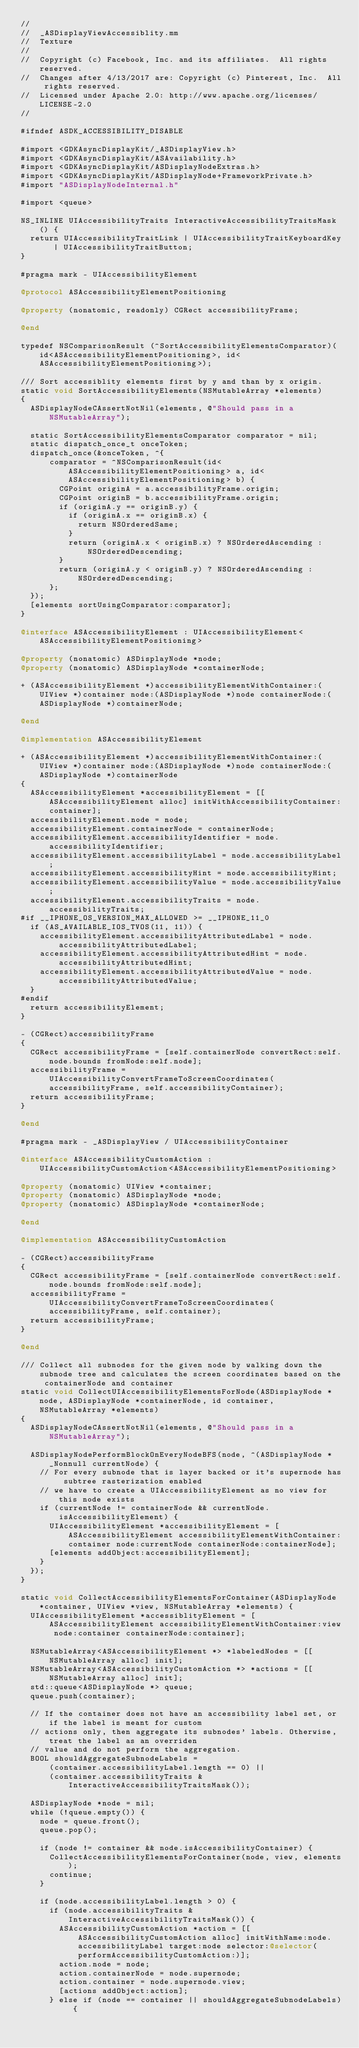<code> <loc_0><loc_0><loc_500><loc_500><_ObjectiveC_>//
//  _ASDisplayViewAccessiblity.mm
//  Texture
//
//  Copyright (c) Facebook, Inc. and its affiliates.  All rights reserved.
//  Changes after 4/13/2017 are: Copyright (c) Pinterest, Inc.  All rights reserved.
//  Licensed under Apache 2.0: http://www.apache.org/licenses/LICENSE-2.0
//

#ifndef ASDK_ACCESSIBILITY_DISABLE

#import <GDKAsyncDisplayKit/_ASDisplayView.h>
#import <GDKAsyncDisplayKit/ASAvailability.h>
#import <GDKAsyncDisplayKit/ASDisplayNodeExtras.h>
#import <GDKAsyncDisplayKit/ASDisplayNode+FrameworkPrivate.h>
#import "ASDisplayNodeInternal.h"

#import <queue>

NS_INLINE UIAccessibilityTraits InteractiveAccessibilityTraitsMask() {
  return UIAccessibilityTraitLink | UIAccessibilityTraitKeyboardKey | UIAccessibilityTraitButton;
}

#pragma mark - UIAccessibilityElement

@protocol ASAccessibilityElementPositioning

@property (nonatomic, readonly) CGRect accessibilityFrame;

@end

typedef NSComparisonResult (^SortAccessibilityElementsComparator)(id<ASAccessibilityElementPositioning>, id<ASAccessibilityElementPositioning>);

/// Sort accessiblity elements first by y and than by x origin.
static void SortAccessibilityElements(NSMutableArray *elements)
{
  ASDisplayNodeCAssertNotNil(elements, @"Should pass in a NSMutableArray");
  
  static SortAccessibilityElementsComparator comparator = nil;
  static dispatch_once_t onceToken;
  dispatch_once(&onceToken, ^{
      comparator = ^NSComparisonResult(id<ASAccessibilityElementPositioning> a, id<ASAccessibilityElementPositioning> b) {
        CGPoint originA = a.accessibilityFrame.origin;
        CGPoint originB = b.accessibilityFrame.origin;
        if (originA.y == originB.y) {
          if (originA.x == originB.x) {
            return NSOrderedSame;
          }
          return (originA.x < originB.x) ? NSOrderedAscending : NSOrderedDescending;
        }
        return (originA.y < originB.y) ? NSOrderedAscending : NSOrderedDescending;
      };
  });
  [elements sortUsingComparator:comparator];
}

@interface ASAccessibilityElement : UIAccessibilityElement<ASAccessibilityElementPositioning>

@property (nonatomic) ASDisplayNode *node;
@property (nonatomic) ASDisplayNode *containerNode;

+ (ASAccessibilityElement *)accessibilityElementWithContainer:(UIView *)container node:(ASDisplayNode *)node containerNode:(ASDisplayNode *)containerNode;

@end

@implementation ASAccessibilityElement

+ (ASAccessibilityElement *)accessibilityElementWithContainer:(UIView *)container node:(ASDisplayNode *)node containerNode:(ASDisplayNode *)containerNode
{
  ASAccessibilityElement *accessibilityElement = [[ASAccessibilityElement alloc] initWithAccessibilityContainer:container];
  accessibilityElement.node = node;
  accessibilityElement.containerNode = containerNode;
  accessibilityElement.accessibilityIdentifier = node.accessibilityIdentifier;
  accessibilityElement.accessibilityLabel = node.accessibilityLabel;
  accessibilityElement.accessibilityHint = node.accessibilityHint;
  accessibilityElement.accessibilityValue = node.accessibilityValue;
  accessibilityElement.accessibilityTraits = node.accessibilityTraits;
#if __IPHONE_OS_VERSION_MAX_ALLOWED >= __IPHONE_11_0
  if (AS_AVAILABLE_IOS_TVOS(11, 11)) {
    accessibilityElement.accessibilityAttributedLabel = node.accessibilityAttributedLabel;
    accessibilityElement.accessibilityAttributedHint = node.accessibilityAttributedHint;
    accessibilityElement.accessibilityAttributedValue = node.accessibilityAttributedValue;
  }
#endif
  return accessibilityElement;
}

- (CGRect)accessibilityFrame
{
  CGRect accessibilityFrame = [self.containerNode convertRect:self.node.bounds fromNode:self.node];
  accessibilityFrame = UIAccessibilityConvertFrameToScreenCoordinates(accessibilityFrame, self.accessibilityContainer);
  return accessibilityFrame;
}

@end

#pragma mark - _ASDisplayView / UIAccessibilityContainer

@interface ASAccessibilityCustomAction : UIAccessibilityCustomAction<ASAccessibilityElementPositioning>

@property (nonatomic) UIView *container;
@property (nonatomic) ASDisplayNode *node;
@property (nonatomic) ASDisplayNode *containerNode;

@end

@implementation ASAccessibilityCustomAction

- (CGRect)accessibilityFrame
{
  CGRect accessibilityFrame = [self.containerNode convertRect:self.node.bounds fromNode:self.node];
  accessibilityFrame = UIAccessibilityConvertFrameToScreenCoordinates(accessibilityFrame, self.container);
  return accessibilityFrame;
}

@end

/// Collect all subnodes for the given node by walking down the subnode tree and calculates the screen coordinates based on the containerNode and container
static void CollectUIAccessibilityElementsForNode(ASDisplayNode *node, ASDisplayNode *containerNode, id container, NSMutableArray *elements)
{
  ASDisplayNodeCAssertNotNil(elements, @"Should pass in a NSMutableArray");
  
  ASDisplayNodePerformBlockOnEveryNodeBFS(node, ^(ASDisplayNode * _Nonnull currentNode) {
    // For every subnode that is layer backed or it's supernode has subtree rasterization enabled
    // we have to create a UIAccessibilityElement as no view for this node exists
    if (currentNode != containerNode && currentNode.isAccessibilityElement) {
      UIAccessibilityElement *accessibilityElement = [ASAccessibilityElement accessibilityElementWithContainer:container node:currentNode containerNode:containerNode];
      [elements addObject:accessibilityElement];
    }
  });
}

static void CollectAccessibilityElementsForContainer(ASDisplayNode *container, UIView *view, NSMutableArray *elements) {
  UIAccessibilityElement *accessiblityElement = [ASAccessibilityElement accessibilityElementWithContainer:view node:container containerNode:container];

  NSMutableArray<ASAccessibilityElement *> *labeledNodes = [[NSMutableArray alloc] init];
  NSMutableArray<ASAccessibilityCustomAction *> *actions = [[NSMutableArray alloc] init];
  std::queue<ASDisplayNode *> queue;
  queue.push(container);

  // If the container does not have an accessibility label set, or if the label is meant for custom
  // actions only, then aggregate its subnodes' labels. Otherwise, treat the label as an overriden
  // value and do not perform the aggregation.
  BOOL shouldAggregateSubnodeLabels =
      (container.accessibilityLabel.length == 0) ||
      (container.accessibilityTraits & InteractiveAccessibilityTraitsMask());

  ASDisplayNode *node = nil;
  while (!queue.empty()) {
    node = queue.front();
    queue.pop();

    if (node != container && node.isAccessibilityContainer) {
      CollectAccessibilityElementsForContainer(node, view, elements);
      continue;
    }

    if (node.accessibilityLabel.length > 0) {
      if (node.accessibilityTraits & InteractiveAccessibilityTraitsMask()) {
        ASAccessibilityCustomAction *action = [[ASAccessibilityCustomAction alloc] initWithName:node.accessibilityLabel target:node selector:@selector(performAccessibilityCustomAction:)];
        action.node = node;
        action.containerNode = node.supernode;
        action.container = node.supernode.view;
        [actions addObject:action];
      } else if (node == container || shouldAggregateSubnodeLabels) {</code> 